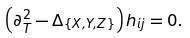<formula> <loc_0><loc_0><loc_500><loc_500>\left ( \partial _ { T } ^ { 2 } - \Delta _ { \{ X , Y , Z \} } \right ) h _ { i j } = 0 .</formula> 